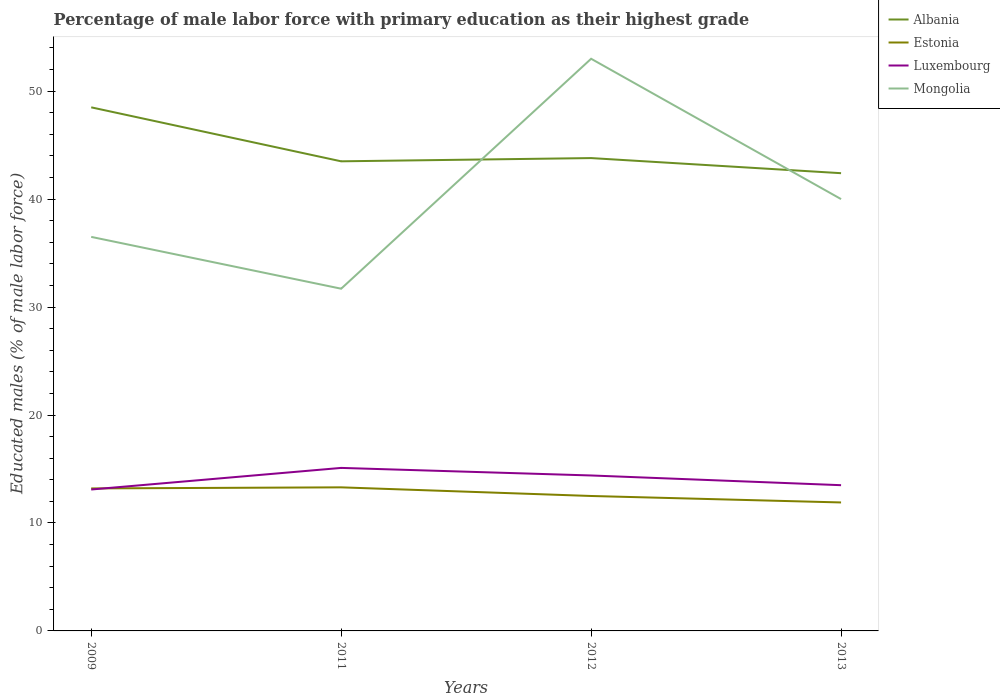How many different coloured lines are there?
Ensure brevity in your answer.  4. Does the line corresponding to Albania intersect with the line corresponding to Mongolia?
Offer a very short reply. Yes. Is the number of lines equal to the number of legend labels?
Ensure brevity in your answer.  Yes. Across all years, what is the maximum percentage of male labor force with primary education in Luxembourg?
Provide a short and direct response. 13.1. In which year was the percentage of male labor force with primary education in Estonia maximum?
Provide a short and direct response. 2013. What is the total percentage of male labor force with primary education in Luxembourg in the graph?
Your answer should be very brief. 0.7. What is the difference between the highest and the lowest percentage of male labor force with primary education in Albania?
Your response must be concise. 1. How many lines are there?
Make the answer very short. 4. What is the difference between two consecutive major ticks on the Y-axis?
Ensure brevity in your answer.  10. Does the graph contain any zero values?
Offer a terse response. No. How many legend labels are there?
Offer a very short reply. 4. What is the title of the graph?
Keep it short and to the point. Percentage of male labor force with primary education as their highest grade. What is the label or title of the X-axis?
Keep it short and to the point. Years. What is the label or title of the Y-axis?
Offer a terse response. Educated males (% of male labor force). What is the Educated males (% of male labor force) of Albania in 2009?
Provide a succinct answer. 48.5. What is the Educated males (% of male labor force) of Estonia in 2009?
Offer a very short reply. 13.2. What is the Educated males (% of male labor force) in Luxembourg in 2009?
Your answer should be compact. 13.1. What is the Educated males (% of male labor force) in Mongolia in 2009?
Offer a terse response. 36.5. What is the Educated males (% of male labor force) of Albania in 2011?
Your response must be concise. 43.5. What is the Educated males (% of male labor force) in Estonia in 2011?
Give a very brief answer. 13.3. What is the Educated males (% of male labor force) in Luxembourg in 2011?
Provide a short and direct response. 15.1. What is the Educated males (% of male labor force) of Mongolia in 2011?
Give a very brief answer. 31.7. What is the Educated males (% of male labor force) of Albania in 2012?
Give a very brief answer. 43.8. What is the Educated males (% of male labor force) of Luxembourg in 2012?
Provide a short and direct response. 14.4. What is the Educated males (% of male labor force) of Mongolia in 2012?
Provide a short and direct response. 53. What is the Educated males (% of male labor force) in Albania in 2013?
Provide a short and direct response. 42.4. What is the Educated males (% of male labor force) of Estonia in 2013?
Your answer should be very brief. 11.9. What is the Educated males (% of male labor force) of Luxembourg in 2013?
Provide a short and direct response. 13.5. What is the Educated males (% of male labor force) in Mongolia in 2013?
Your answer should be very brief. 40. Across all years, what is the maximum Educated males (% of male labor force) in Albania?
Your answer should be very brief. 48.5. Across all years, what is the maximum Educated males (% of male labor force) in Estonia?
Give a very brief answer. 13.3. Across all years, what is the maximum Educated males (% of male labor force) in Luxembourg?
Ensure brevity in your answer.  15.1. Across all years, what is the maximum Educated males (% of male labor force) in Mongolia?
Offer a very short reply. 53. Across all years, what is the minimum Educated males (% of male labor force) of Albania?
Offer a terse response. 42.4. Across all years, what is the minimum Educated males (% of male labor force) in Estonia?
Your response must be concise. 11.9. Across all years, what is the minimum Educated males (% of male labor force) in Luxembourg?
Make the answer very short. 13.1. Across all years, what is the minimum Educated males (% of male labor force) of Mongolia?
Keep it short and to the point. 31.7. What is the total Educated males (% of male labor force) of Albania in the graph?
Provide a succinct answer. 178.2. What is the total Educated males (% of male labor force) of Estonia in the graph?
Provide a succinct answer. 50.9. What is the total Educated males (% of male labor force) in Luxembourg in the graph?
Keep it short and to the point. 56.1. What is the total Educated males (% of male labor force) in Mongolia in the graph?
Provide a succinct answer. 161.2. What is the difference between the Educated males (% of male labor force) of Albania in 2009 and that in 2011?
Your response must be concise. 5. What is the difference between the Educated males (% of male labor force) in Mongolia in 2009 and that in 2011?
Offer a very short reply. 4.8. What is the difference between the Educated males (% of male labor force) in Albania in 2009 and that in 2012?
Keep it short and to the point. 4.7. What is the difference between the Educated males (% of male labor force) in Mongolia in 2009 and that in 2012?
Your response must be concise. -16.5. What is the difference between the Educated males (% of male labor force) in Estonia in 2009 and that in 2013?
Keep it short and to the point. 1.3. What is the difference between the Educated males (% of male labor force) of Luxembourg in 2009 and that in 2013?
Provide a short and direct response. -0.4. What is the difference between the Educated males (% of male labor force) of Albania in 2011 and that in 2012?
Give a very brief answer. -0.3. What is the difference between the Educated males (% of male labor force) in Estonia in 2011 and that in 2012?
Make the answer very short. 0.8. What is the difference between the Educated males (% of male labor force) of Mongolia in 2011 and that in 2012?
Your response must be concise. -21.3. What is the difference between the Educated males (% of male labor force) of Luxembourg in 2011 and that in 2013?
Provide a succinct answer. 1.6. What is the difference between the Educated males (% of male labor force) in Albania in 2012 and that in 2013?
Provide a short and direct response. 1.4. What is the difference between the Educated males (% of male labor force) in Estonia in 2012 and that in 2013?
Provide a succinct answer. 0.6. What is the difference between the Educated males (% of male labor force) in Luxembourg in 2012 and that in 2013?
Provide a short and direct response. 0.9. What is the difference between the Educated males (% of male labor force) in Albania in 2009 and the Educated males (% of male labor force) in Estonia in 2011?
Offer a very short reply. 35.2. What is the difference between the Educated males (% of male labor force) of Albania in 2009 and the Educated males (% of male labor force) of Luxembourg in 2011?
Your answer should be very brief. 33.4. What is the difference between the Educated males (% of male labor force) in Albania in 2009 and the Educated males (% of male labor force) in Mongolia in 2011?
Give a very brief answer. 16.8. What is the difference between the Educated males (% of male labor force) of Estonia in 2009 and the Educated males (% of male labor force) of Luxembourg in 2011?
Your response must be concise. -1.9. What is the difference between the Educated males (% of male labor force) in Estonia in 2009 and the Educated males (% of male labor force) in Mongolia in 2011?
Your answer should be compact. -18.5. What is the difference between the Educated males (% of male labor force) in Luxembourg in 2009 and the Educated males (% of male labor force) in Mongolia in 2011?
Keep it short and to the point. -18.6. What is the difference between the Educated males (% of male labor force) of Albania in 2009 and the Educated males (% of male labor force) of Estonia in 2012?
Offer a terse response. 36. What is the difference between the Educated males (% of male labor force) in Albania in 2009 and the Educated males (% of male labor force) in Luxembourg in 2012?
Provide a succinct answer. 34.1. What is the difference between the Educated males (% of male labor force) in Albania in 2009 and the Educated males (% of male labor force) in Mongolia in 2012?
Provide a succinct answer. -4.5. What is the difference between the Educated males (% of male labor force) in Estonia in 2009 and the Educated males (% of male labor force) in Luxembourg in 2012?
Give a very brief answer. -1.2. What is the difference between the Educated males (% of male labor force) in Estonia in 2009 and the Educated males (% of male labor force) in Mongolia in 2012?
Keep it short and to the point. -39.8. What is the difference between the Educated males (% of male labor force) in Luxembourg in 2009 and the Educated males (% of male labor force) in Mongolia in 2012?
Offer a very short reply. -39.9. What is the difference between the Educated males (% of male labor force) of Albania in 2009 and the Educated males (% of male labor force) of Estonia in 2013?
Make the answer very short. 36.6. What is the difference between the Educated males (% of male labor force) of Albania in 2009 and the Educated males (% of male labor force) of Luxembourg in 2013?
Provide a short and direct response. 35. What is the difference between the Educated males (% of male labor force) of Albania in 2009 and the Educated males (% of male labor force) of Mongolia in 2013?
Your answer should be very brief. 8.5. What is the difference between the Educated males (% of male labor force) of Estonia in 2009 and the Educated males (% of male labor force) of Luxembourg in 2013?
Make the answer very short. -0.3. What is the difference between the Educated males (% of male labor force) of Estonia in 2009 and the Educated males (% of male labor force) of Mongolia in 2013?
Make the answer very short. -26.8. What is the difference between the Educated males (% of male labor force) of Luxembourg in 2009 and the Educated males (% of male labor force) of Mongolia in 2013?
Make the answer very short. -26.9. What is the difference between the Educated males (% of male labor force) in Albania in 2011 and the Educated males (% of male labor force) in Luxembourg in 2012?
Provide a short and direct response. 29.1. What is the difference between the Educated males (% of male labor force) of Estonia in 2011 and the Educated males (% of male labor force) of Mongolia in 2012?
Your answer should be compact. -39.7. What is the difference between the Educated males (% of male labor force) of Luxembourg in 2011 and the Educated males (% of male labor force) of Mongolia in 2012?
Provide a short and direct response. -37.9. What is the difference between the Educated males (% of male labor force) in Albania in 2011 and the Educated males (% of male labor force) in Estonia in 2013?
Give a very brief answer. 31.6. What is the difference between the Educated males (% of male labor force) of Albania in 2011 and the Educated males (% of male labor force) of Mongolia in 2013?
Ensure brevity in your answer.  3.5. What is the difference between the Educated males (% of male labor force) in Estonia in 2011 and the Educated males (% of male labor force) in Mongolia in 2013?
Give a very brief answer. -26.7. What is the difference between the Educated males (% of male labor force) of Luxembourg in 2011 and the Educated males (% of male labor force) of Mongolia in 2013?
Give a very brief answer. -24.9. What is the difference between the Educated males (% of male labor force) in Albania in 2012 and the Educated males (% of male labor force) in Estonia in 2013?
Your answer should be compact. 31.9. What is the difference between the Educated males (% of male labor force) of Albania in 2012 and the Educated males (% of male labor force) of Luxembourg in 2013?
Your answer should be very brief. 30.3. What is the difference between the Educated males (% of male labor force) in Estonia in 2012 and the Educated males (% of male labor force) in Luxembourg in 2013?
Provide a succinct answer. -1. What is the difference between the Educated males (% of male labor force) in Estonia in 2012 and the Educated males (% of male labor force) in Mongolia in 2013?
Keep it short and to the point. -27.5. What is the difference between the Educated males (% of male labor force) of Luxembourg in 2012 and the Educated males (% of male labor force) of Mongolia in 2013?
Provide a succinct answer. -25.6. What is the average Educated males (% of male labor force) of Albania per year?
Offer a terse response. 44.55. What is the average Educated males (% of male labor force) in Estonia per year?
Provide a succinct answer. 12.72. What is the average Educated males (% of male labor force) of Luxembourg per year?
Your response must be concise. 14.03. What is the average Educated males (% of male labor force) of Mongolia per year?
Your response must be concise. 40.3. In the year 2009, what is the difference between the Educated males (% of male labor force) of Albania and Educated males (% of male labor force) of Estonia?
Keep it short and to the point. 35.3. In the year 2009, what is the difference between the Educated males (% of male labor force) in Albania and Educated males (% of male labor force) in Luxembourg?
Your answer should be compact. 35.4. In the year 2009, what is the difference between the Educated males (% of male labor force) of Albania and Educated males (% of male labor force) of Mongolia?
Your response must be concise. 12. In the year 2009, what is the difference between the Educated males (% of male labor force) in Estonia and Educated males (% of male labor force) in Mongolia?
Offer a very short reply. -23.3. In the year 2009, what is the difference between the Educated males (% of male labor force) in Luxembourg and Educated males (% of male labor force) in Mongolia?
Your answer should be compact. -23.4. In the year 2011, what is the difference between the Educated males (% of male labor force) in Albania and Educated males (% of male labor force) in Estonia?
Keep it short and to the point. 30.2. In the year 2011, what is the difference between the Educated males (% of male labor force) in Albania and Educated males (% of male labor force) in Luxembourg?
Give a very brief answer. 28.4. In the year 2011, what is the difference between the Educated males (% of male labor force) in Estonia and Educated males (% of male labor force) in Luxembourg?
Keep it short and to the point. -1.8. In the year 2011, what is the difference between the Educated males (% of male labor force) of Estonia and Educated males (% of male labor force) of Mongolia?
Your answer should be compact. -18.4. In the year 2011, what is the difference between the Educated males (% of male labor force) of Luxembourg and Educated males (% of male labor force) of Mongolia?
Your response must be concise. -16.6. In the year 2012, what is the difference between the Educated males (% of male labor force) in Albania and Educated males (% of male labor force) in Estonia?
Ensure brevity in your answer.  31.3. In the year 2012, what is the difference between the Educated males (% of male labor force) of Albania and Educated males (% of male labor force) of Luxembourg?
Make the answer very short. 29.4. In the year 2012, what is the difference between the Educated males (% of male labor force) of Albania and Educated males (% of male labor force) of Mongolia?
Your answer should be compact. -9.2. In the year 2012, what is the difference between the Educated males (% of male labor force) in Estonia and Educated males (% of male labor force) in Luxembourg?
Your answer should be compact. -1.9. In the year 2012, what is the difference between the Educated males (% of male labor force) in Estonia and Educated males (% of male labor force) in Mongolia?
Your answer should be compact. -40.5. In the year 2012, what is the difference between the Educated males (% of male labor force) in Luxembourg and Educated males (% of male labor force) in Mongolia?
Your answer should be compact. -38.6. In the year 2013, what is the difference between the Educated males (% of male labor force) of Albania and Educated males (% of male labor force) of Estonia?
Your response must be concise. 30.5. In the year 2013, what is the difference between the Educated males (% of male labor force) in Albania and Educated males (% of male labor force) in Luxembourg?
Keep it short and to the point. 28.9. In the year 2013, what is the difference between the Educated males (% of male labor force) in Albania and Educated males (% of male labor force) in Mongolia?
Your response must be concise. 2.4. In the year 2013, what is the difference between the Educated males (% of male labor force) of Estonia and Educated males (% of male labor force) of Luxembourg?
Provide a succinct answer. -1.6. In the year 2013, what is the difference between the Educated males (% of male labor force) in Estonia and Educated males (% of male labor force) in Mongolia?
Your answer should be compact. -28.1. In the year 2013, what is the difference between the Educated males (% of male labor force) of Luxembourg and Educated males (% of male labor force) of Mongolia?
Offer a very short reply. -26.5. What is the ratio of the Educated males (% of male labor force) of Albania in 2009 to that in 2011?
Your answer should be very brief. 1.11. What is the ratio of the Educated males (% of male labor force) in Luxembourg in 2009 to that in 2011?
Your answer should be very brief. 0.87. What is the ratio of the Educated males (% of male labor force) of Mongolia in 2009 to that in 2011?
Make the answer very short. 1.15. What is the ratio of the Educated males (% of male labor force) in Albania in 2009 to that in 2012?
Ensure brevity in your answer.  1.11. What is the ratio of the Educated males (% of male labor force) in Estonia in 2009 to that in 2012?
Offer a terse response. 1.06. What is the ratio of the Educated males (% of male labor force) in Luxembourg in 2009 to that in 2012?
Keep it short and to the point. 0.91. What is the ratio of the Educated males (% of male labor force) of Mongolia in 2009 to that in 2012?
Offer a terse response. 0.69. What is the ratio of the Educated males (% of male labor force) in Albania in 2009 to that in 2013?
Your response must be concise. 1.14. What is the ratio of the Educated males (% of male labor force) of Estonia in 2009 to that in 2013?
Give a very brief answer. 1.11. What is the ratio of the Educated males (% of male labor force) in Luxembourg in 2009 to that in 2013?
Ensure brevity in your answer.  0.97. What is the ratio of the Educated males (% of male labor force) of Mongolia in 2009 to that in 2013?
Offer a very short reply. 0.91. What is the ratio of the Educated males (% of male labor force) in Albania in 2011 to that in 2012?
Provide a short and direct response. 0.99. What is the ratio of the Educated males (% of male labor force) in Estonia in 2011 to that in 2012?
Your response must be concise. 1.06. What is the ratio of the Educated males (% of male labor force) in Luxembourg in 2011 to that in 2012?
Your answer should be very brief. 1.05. What is the ratio of the Educated males (% of male labor force) in Mongolia in 2011 to that in 2012?
Keep it short and to the point. 0.6. What is the ratio of the Educated males (% of male labor force) in Albania in 2011 to that in 2013?
Provide a succinct answer. 1.03. What is the ratio of the Educated males (% of male labor force) in Estonia in 2011 to that in 2013?
Offer a very short reply. 1.12. What is the ratio of the Educated males (% of male labor force) in Luxembourg in 2011 to that in 2013?
Your response must be concise. 1.12. What is the ratio of the Educated males (% of male labor force) of Mongolia in 2011 to that in 2013?
Your response must be concise. 0.79. What is the ratio of the Educated males (% of male labor force) of Albania in 2012 to that in 2013?
Ensure brevity in your answer.  1.03. What is the ratio of the Educated males (% of male labor force) in Estonia in 2012 to that in 2013?
Ensure brevity in your answer.  1.05. What is the ratio of the Educated males (% of male labor force) of Luxembourg in 2012 to that in 2013?
Offer a terse response. 1.07. What is the ratio of the Educated males (% of male labor force) in Mongolia in 2012 to that in 2013?
Provide a short and direct response. 1.32. What is the difference between the highest and the second highest Educated males (% of male labor force) in Mongolia?
Your response must be concise. 13. What is the difference between the highest and the lowest Educated males (% of male labor force) of Mongolia?
Provide a short and direct response. 21.3. 